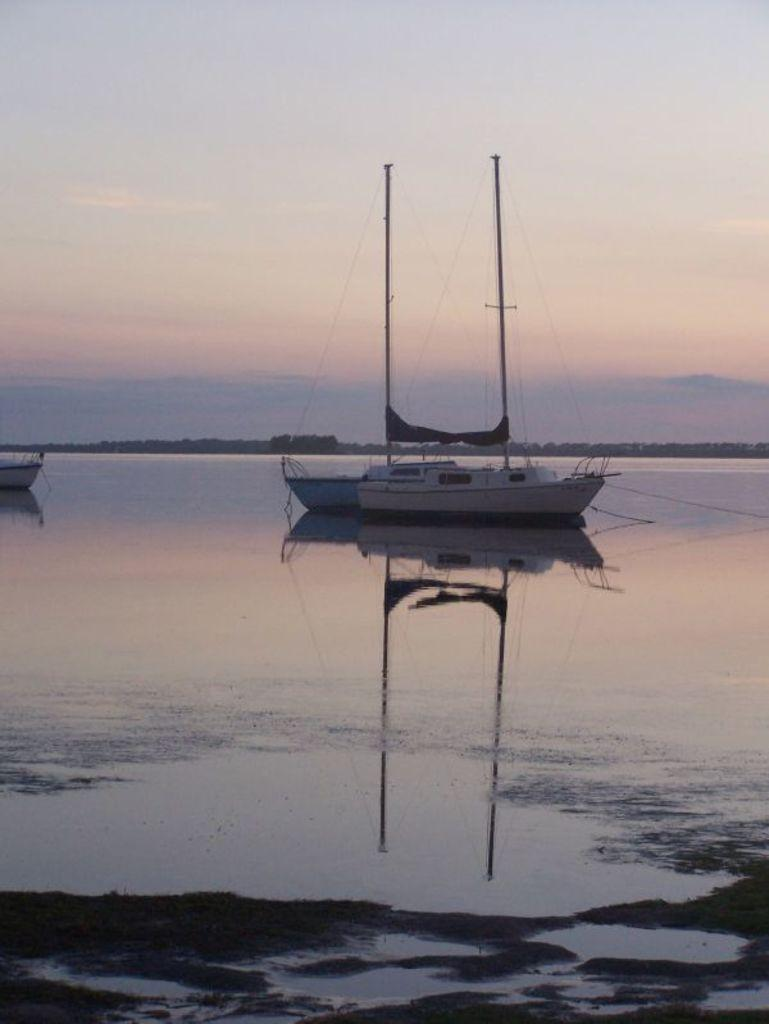What type of vehicles can be seen in the image? There are boats in the image. Where are the boats located? The boats are on the water. What can be seen in the background of the image? There is sky visible in the background of the image. What is the condition of the sky in the image? Clouds are present in the sky. What emotion do the boats express in the image? Boats do not have emotions, so this question cannot be answered. 